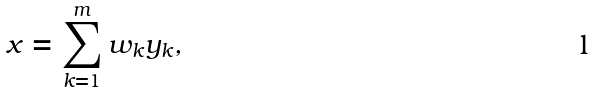<formula> <loc_0><loc_0><loc_500><loc_500>x = \sum _ { k = 1 } ^ { m } w _ { k } y _ { k } ,</formula> 